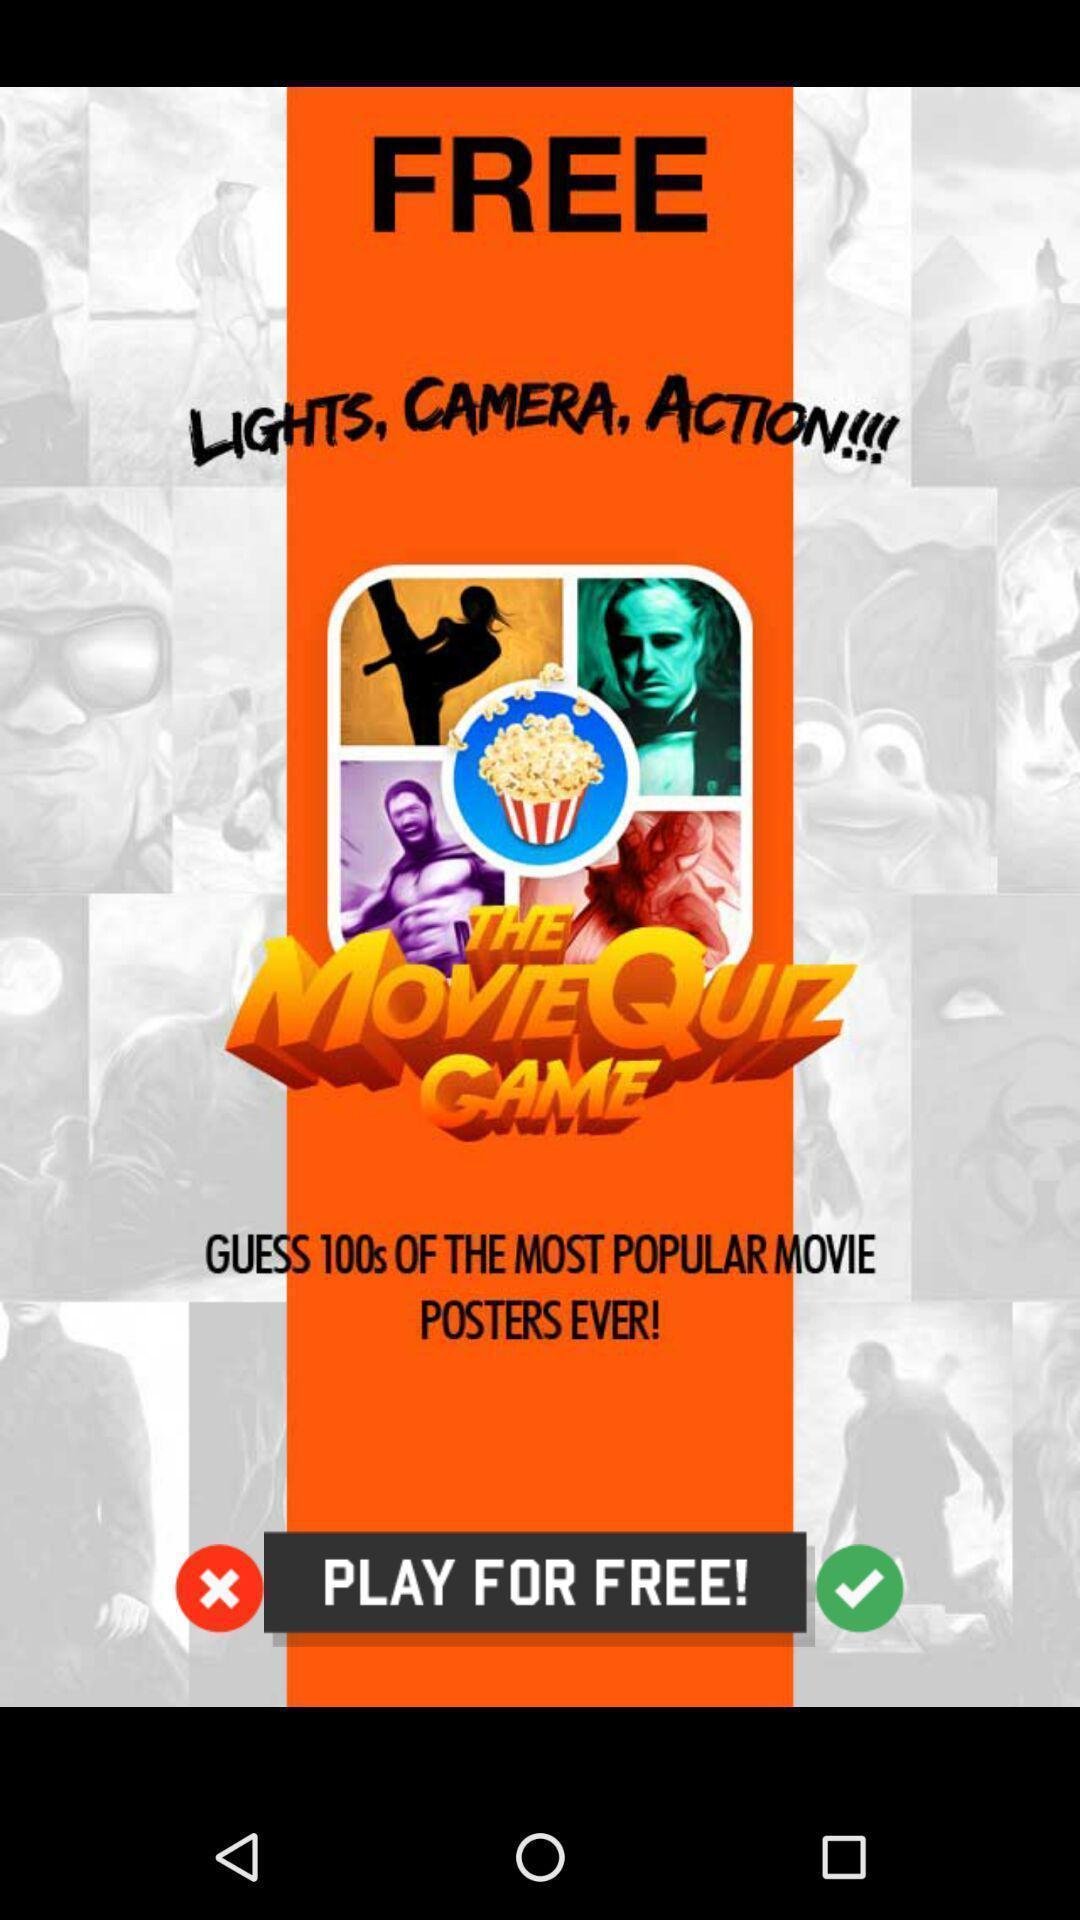Explain the elements present in this screenshot. Starting page. 